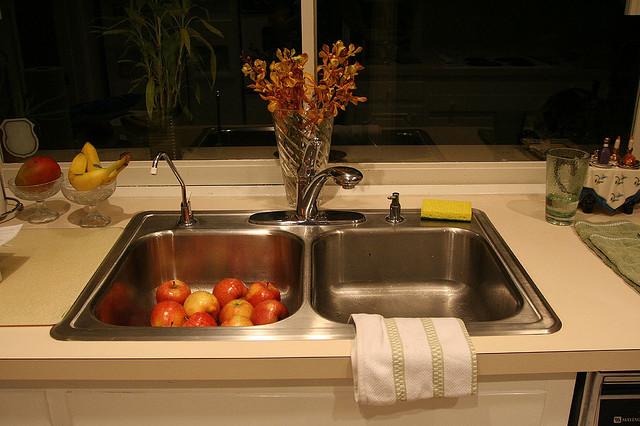What is the fruit to the left of the bananas?
Write a very short answer. Mango. How many apples are in the sink?
Answer briefly. 9. Is it an indoor scene?
Write a very short answer. Yes. Is this photo taken at a bakery?
Write a very short answer. No. 